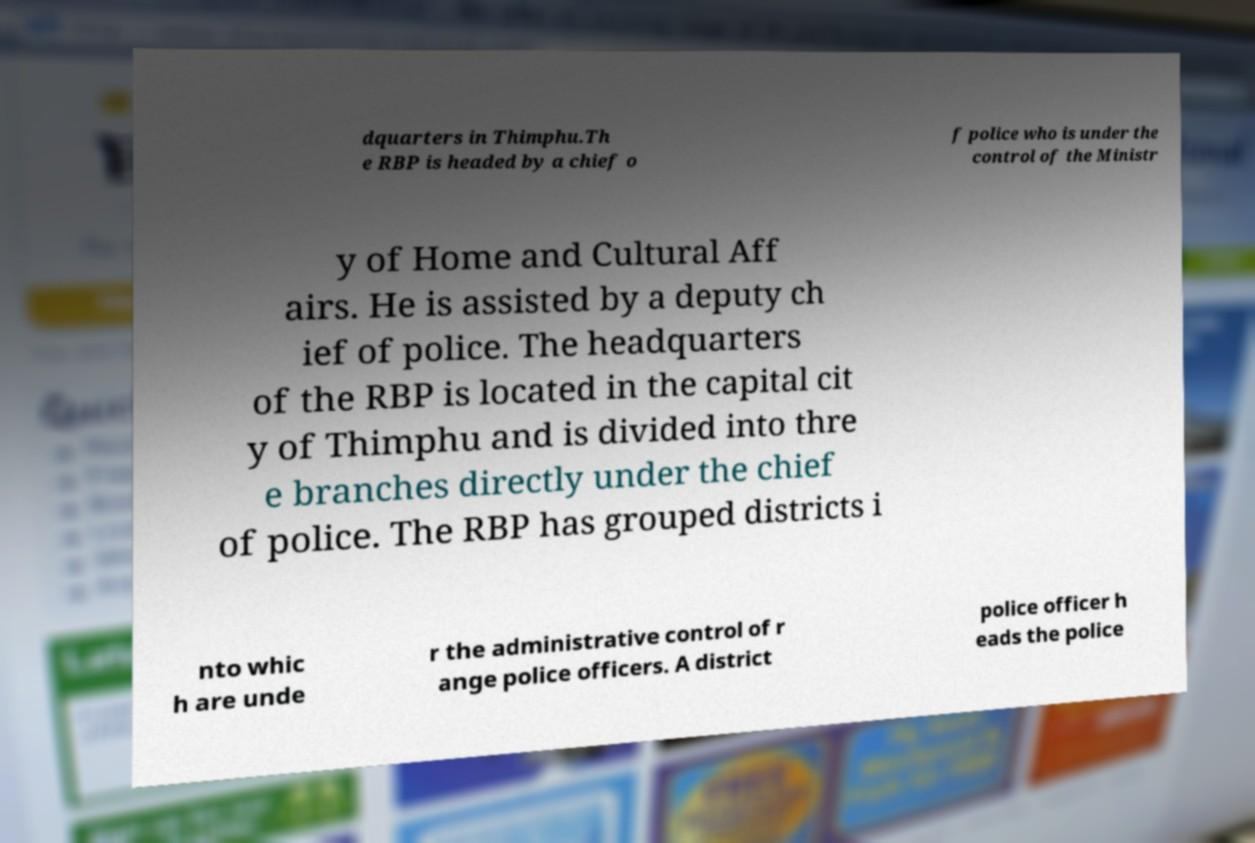Can you accurately transcribe the text from the provided image for me? dquarters in Thimphu.Th e RBP is headed by a chief o f police who is under the control of the Ministr y of Home and Cultural Aff airs. He is assisted by a deputy ch ief of police. The headquarters of the RBP is located in the capital cit y of Thimphu and is divided into thre e branches directly under the chief of police. The RBP has grouped districts i nto whic h are unde r the administrative control of r ange police officers. A district police officer h eads the police 